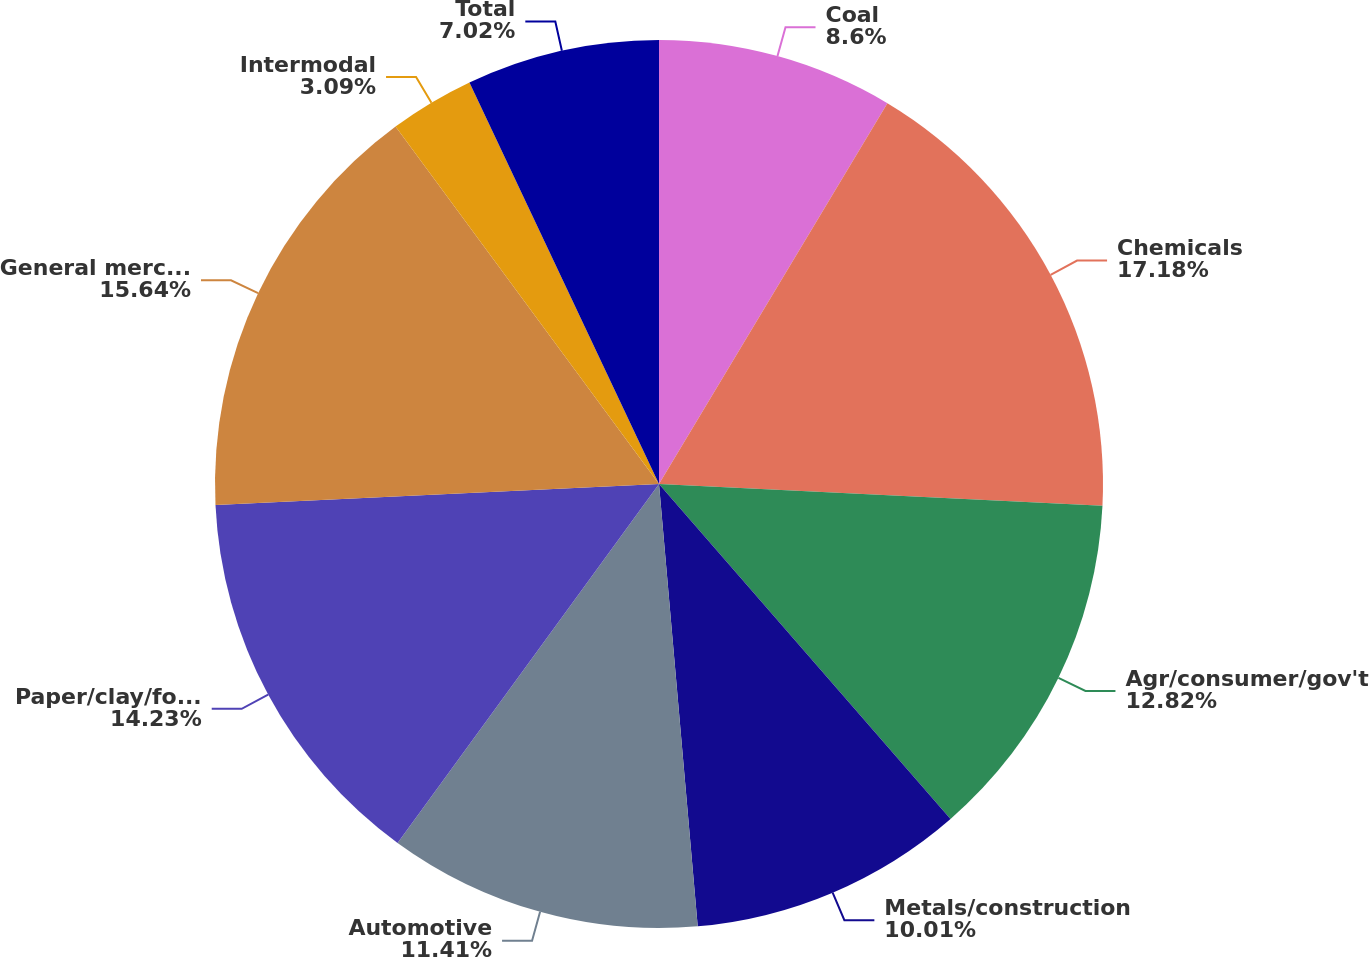Convert chart to OTSL. <chart><loc_0><loc_0><loc_500><loc_500><pie_chart><fcel>Coal<fcel>Chemicals<fcel>Agr/consumer/gov't<fcel>Metals/construction<fcel>Automotive<fcel>Paper/clay/forest<fcel>General merchandise<fcel>Intermodal<fcel>Total<nl><fcel>8.6%<fcel>17.18%<fcel>12.82%<fcel>10.01%<fcel>11.41%<fcel>14.23%<fcel>15.64%<fcel>3.09%<fcel>7.02%<nl></chart> 